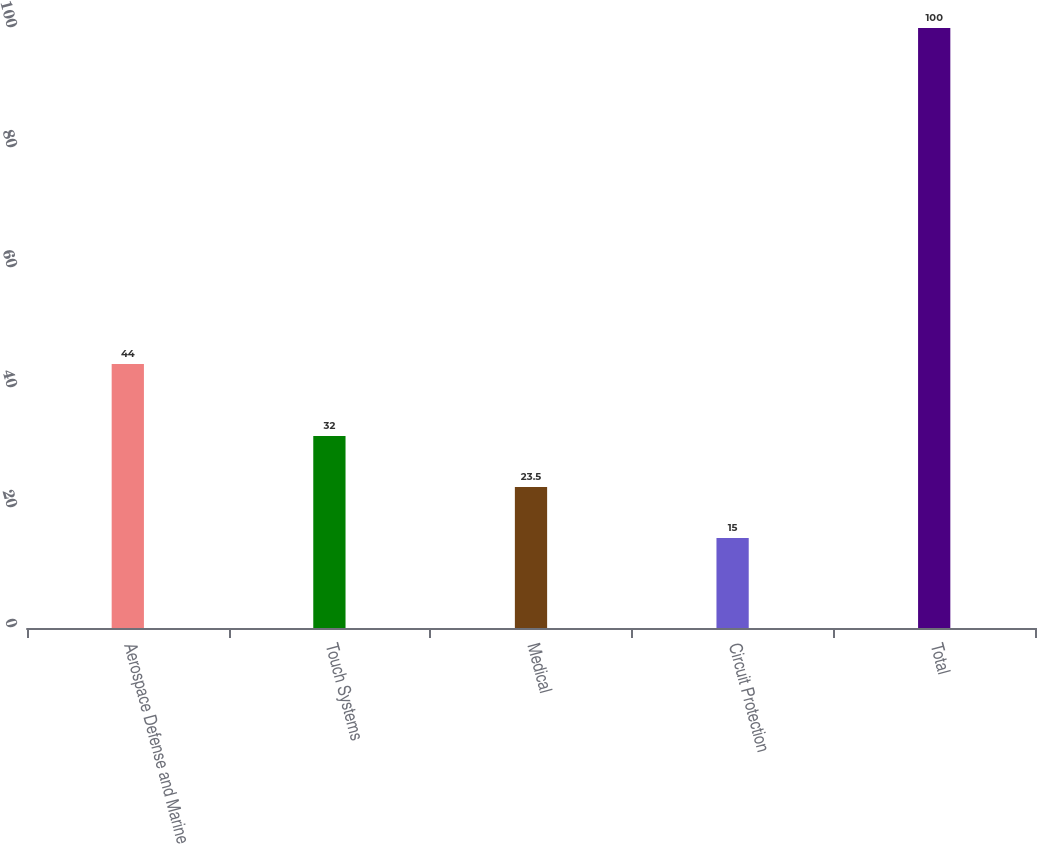Convert chart. <chart><loc_0><loc_0><loc_500><loc_500><bar_chart><fcel>Aerospace Defense and Marine<fcel>Touch Systems<fcel>Medical<fcel>Circuit Protection<fcel>Total<nl><fcel>44<fcel>32<fcel>23.5<fcel>15<fcel>100<nl></chart> 